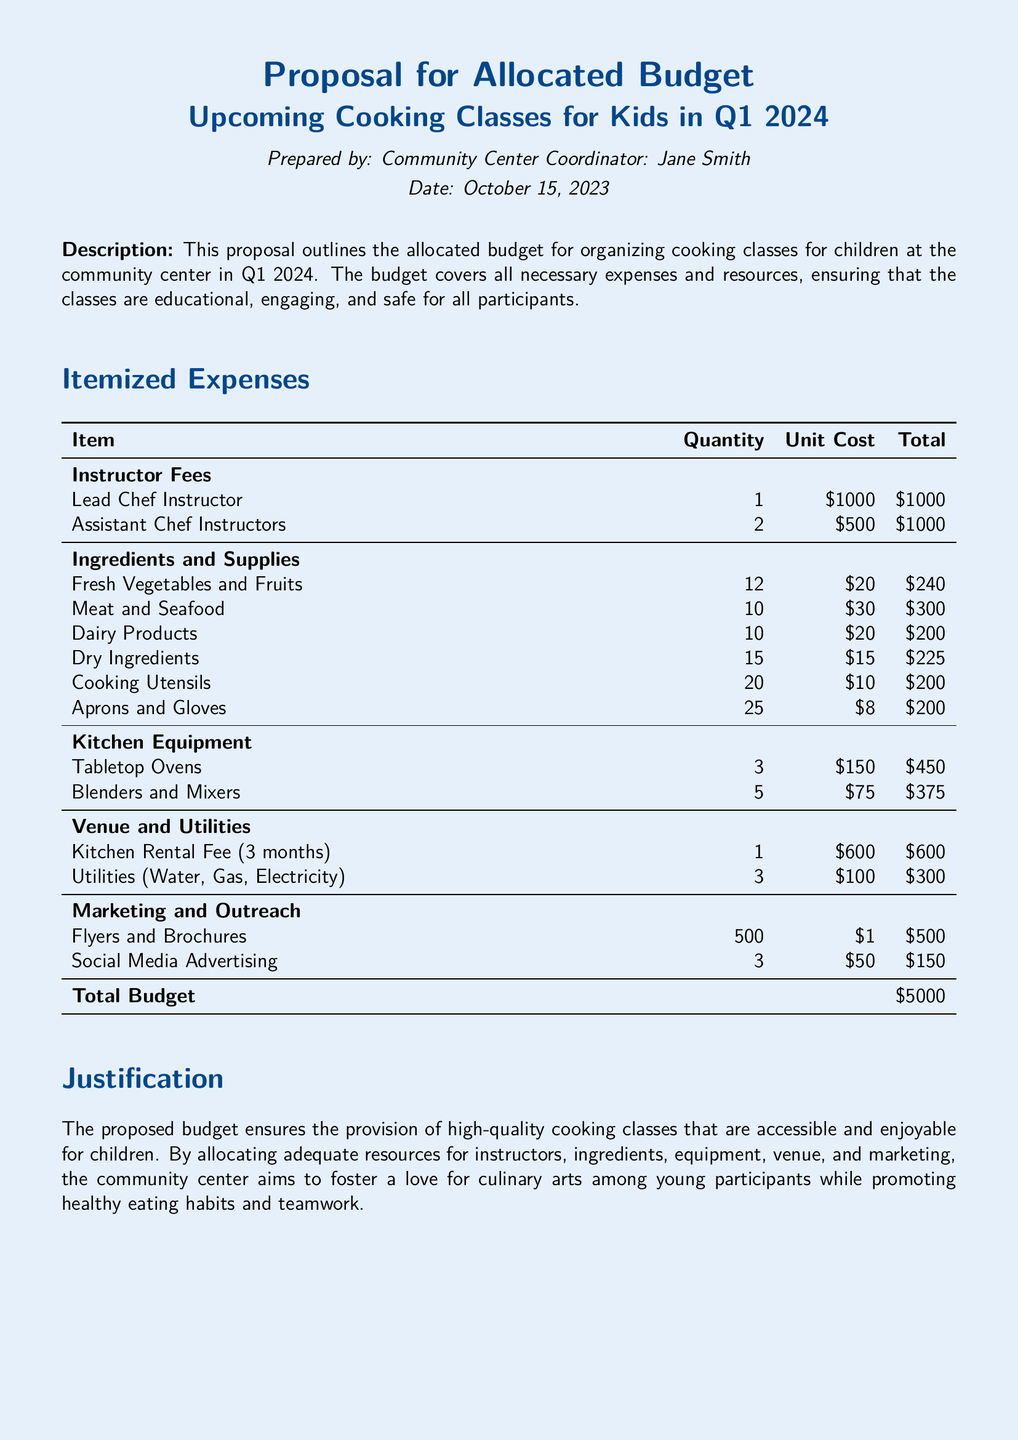What is the total budget for the cooking classes? The total budget is listed at the bottom of the itemized expenses table.
Answer: $5000 Who prepared the proposal? The document states the name of the community center coordinator who prepared the proposal.
Answer: Jane Smith How many assistant chef instructors are included in the budget? The budget specifies the quantity of assistant chef instructors listed under instructor fees.
Answer: 2 What is the unit cost of fresh vegetables and fruits? The unit cost is provided in the itemized table under ingredients and supplies.
Answer: $20 How long is the kitchen rental fee allocated for? The document indicates the rental fee duration mentioned in the venue and utilities section.
Answer: 3 months What is the total cost for dairy products? The total cost is obtained by multiplying the quantity by the unit cost as provided in the document.
Answer: $200 What is one of the goals of the cooking classes as outlined in the justification? The justification section mentions key goals for the cooking classes.
Answer: Healthy eating habits How many tabletop ovens are included in the budget? The itemized expenses table indicates the quantity of tabletop ovens needed for the classes.
Answer: 3 What is the cost for social media advertising? The total cost of social media advertising is listed in the marketing and outreach section.
Answer: $150 